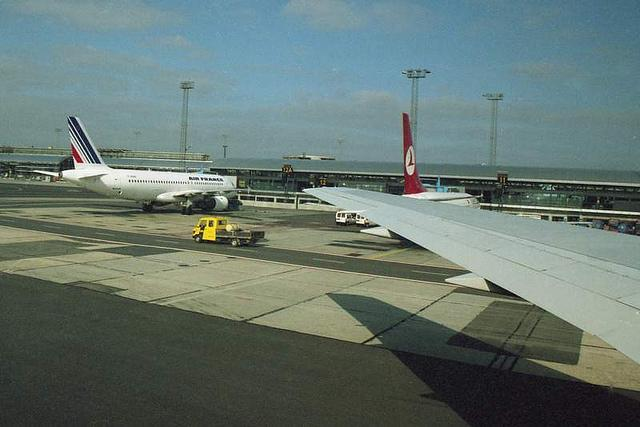What fuel does the plane require? jet fuel 